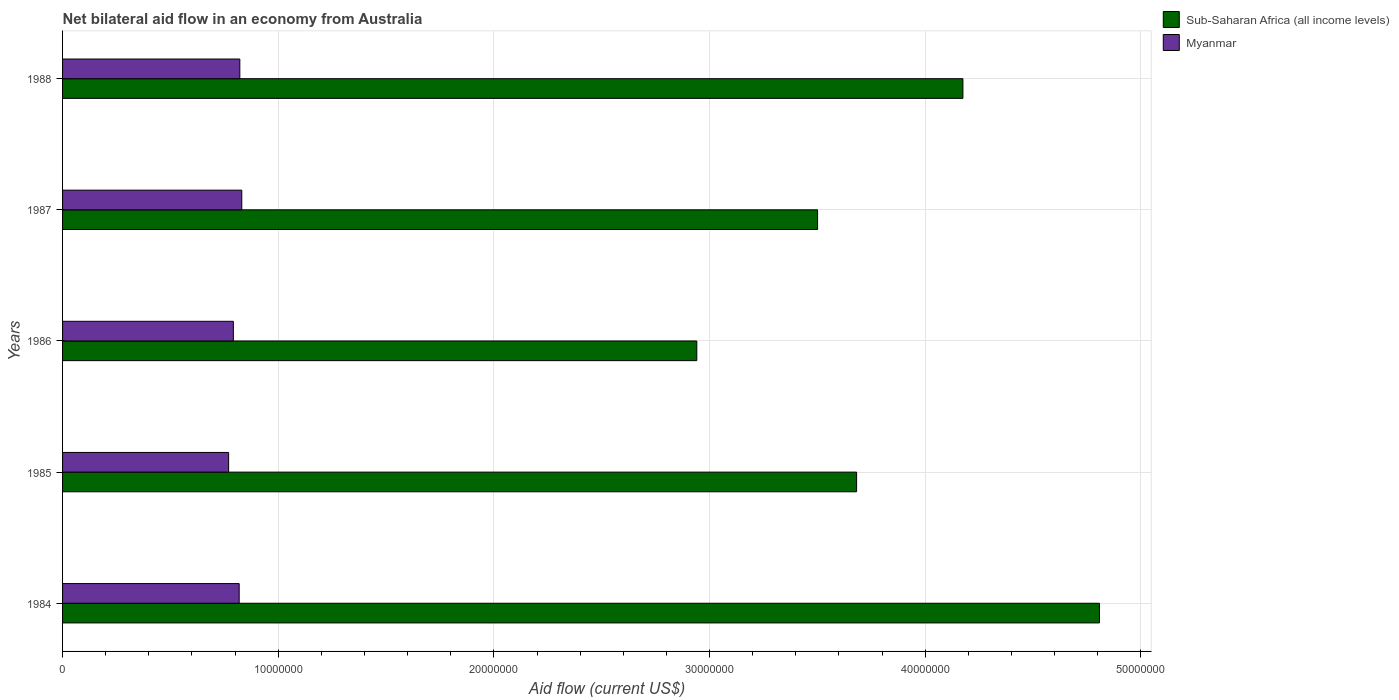How many groups of bars are there?
Provide a succinct answer. 5. Are the number of bars per tick equal to the number of legend labels?
Keep it short and to the point. Yes. How many bars are there on the 1st tick from the top?
Give a very brief answer. 2. How many bars are there on the 5th tick from the bottom?
Offer a very short reply. 2. What is the label of the 3rd group of bars from the top?
Offer a very short reply. 1986. In how many cases, is the number of bars for a given year not equal to the number of legend labels?
Provide a short and direct response. 0. What is the net bilateral aid flow in Sub-Saharan Africa (all income levels) in 1987?
Your answer should be very brief. 3.50e+07. Across all years, what is the maximum net bilateral aid flow in Myanmar?
Provide a short and direct response. 8.31e+06. Across all years, what is the minimum net bilateral aid flow in Sub-Saharan Africa (all income levels)?
Your answer should be very brief. 2.94e+07. In which year was the net bilateral aid flow in Sub-Saharan Africa (all income levels) minimum?
Keep it short and to the point. 1986. What is the total net bilateral aid flow in Myanmar in the graph?
Provide a succinct answer. 4.03e+07. What is the difference between the net bilateral aid flow in Myanmar in 1985 and that in 1987?
Keep it short and to the point. -6.10e+05. What is the difference between the net bilateral aid flow in Sub-Saharan Africa (all income levels) in 1987 and the net bilateral aid flow in Myanmar in 1984?
Your answer should be compact. 2.68e+07. What is the average net bilateral aid flow in Sub-Saharan Africa (all income levels) per year?
Make the answer very short. 3.82e+07. In the year 1984, what is the difference between the net bilateral aid flow in Sub-Saharan Africa (all income levels) and net bilateral aid flow in Myanmar?
Provide a short and direct response. 3.99e+07. What is the ratio of the net bilateral aid flow in Sub-Saharan Africa (all income levels) in 1984 to that in 1985?
Make the answer very short. 1.31. Is the net bilateral aid flow in Myanmar in 1984 less than that in 1986?
Your answer should be compact. No. Is the difference between the net bilateral aid flow in Sub-Saharan Africa (all income levels) in 1985 and 1988 greater than the difference between the net bilateral aid flow in Myanmar in 1985 and 1988?
Offer a very short reply. No. What is the difference between the highest and the second highest net bilateral aid flow in Myanmar?
Offer a very short reply. 9.00e+04. What is the difference between the highest and the lowest net bilateral aid flow in Myanmar?
Offer a terse response. 6.10e+05. In how many years, is the net bilateral aid flow in Sub-Saharan Africa (all income levels) greater than the average net bilateral aid flow in Sub-Saharan Africa (all income levels) taken over all years?
Your answer should be compact. 2. Is the sum of the net bilateral aid flow in Myanmar in 1984 and 1988 greater than the maximum net bilateral aid flow in Sub-Saharan Africa (all income levels) across all years?
Make the answer very short. No. What does the 2nd bar from the top in 1988 represents?
Ensure brevity in your answer.  Sub-Saharan Africa (all income levels). What does the 2nd bar from the bottom in 1985 represents?
Provide a succinct answer. Myanmar. What is the difference between two consecutive major ticks on the X-axis?
Make the answer very short. 1.00e+07. Are the values on the major ticks of X-axis written in scientific E-notation?
Give a very brief answer. No. Does the graph contain any zero values?
Give a very brief answer. No. Where does the legend appear in the graph?
Your answer should be compact. Top right. What is the title of the graph?
Make the answer very short. Net bilateral aid flow in an economy from Australia. Does "Dominica" appear as one of the legend labels in the graph?
Your answer should be compact. No. What is the label or title of the Y-axis?
Offer a very short reply. Years. What is the Aid flow (current US$) in Sub-Saharan Africa (all income levels) in 1984?
Your answer should be very brief. 4.81e+07. What is the Aid flow (current US$) in Myanmar in 1984?
Your answer should be compact. 8.19e+06. What is the Aid flow (current US$) of Sub-Saharan Africa (all income levels) in 1985?
Your response must be concise. 3.68e+07. What is the Aid flow (current US$) of Myanmar in 1985?
Give a very brief answer. 7.70e+06. What is the Aid flow (current US$) of Sub-Saharan Africa (all income levels) in 1986?
Offer a terse response. 2.94e+07. What is the Aid flow (current US$) of Myanmar in 1986?
Your response must be concise. 7.92e+06. What is the Aid flow (current US$) of Sub-Saharan Africa (all income levels) in 1987?
Give a very brief answer. 3.50e+07. What is the Aid flow (current US$) of Myanmar in 1987?
Offer a very short reply. 8.31e+06. What is the Aid flow (current US$) of Sub-Saharan Africa (all income levels) in 1988?
Provide a short and direct response. 4.18e+07. What is the Aid flow (current US$) in Myanmar in 1988?
Your response must be concise. 8.22e+06. Across all years, what is the maximum Aid flow (current US$) of Sub-Saharan Africa (all income levels)?
Your answer should be compact. 4.81e+07. Across all years, what is the maximum Aid flow (current US$) of Myanmar?
Provide a short and direct response. 8.31e+06. Across all years, what is the minimum Aid flow (current US$) in Sub-Saharan Africa (all income levels)?
Your answer should be compact. 2.94e+07. Across all years, what is the minimum Aid flow (current US$) of Myanmar?
Provide a short and direct response. 7.70e+06. What is the total Aid flow (current US$) in Sub-Saharan Africa (all income levels) in the graph?
Your answer should be compact. 1.91e+08. What is the total Aid flow (current US$) of Myanmar in the graph?
Make the answer very short. 4.03e+07. What is the difference between the Aid flow (current US$) in Sub-Saharan Africa (all income levels) in 1984 and that in 1985?
Your answer should be compact. 1.13e+07. What is the difference between the Aid flow (current US$) in Sub-Saharan Africa (all income levels) in 1984 and that in 1986?
Your answer should be compact. 1.87e+07. What is the difference between the Aid flow (current US$) of Myanmar in 1984 and that in 1986?
Give a very brief answer. 2.70e+05. What is the difference between the Aid flow (current US$) in Sub-Saharan Africa (all income levels) in 1984 and that in 1987?
Keep it short and to the point. 1.31e+07. What is the difference between the Aid flow (current US$) in Sub-Saharan Africa (all income levels) in 1984 and that in 1988?
Provide a short and direct response. 6.33e+06. What is the difference between the Aid flow (current US$) in Myanmar in 1984 and that in 1988?
Offer a terse response. -3.00e+04. What is the difference between the Aid flow (current US$) in Sub-Saharan Africa (all income levels) in 1985 and that in 1986?
Make the answer very short. 7.41e+06. What is the difference between the Aid flow (current US$) in Myanmar in 1985 and that in 1986?
Your answer should be compact. -2.20e+05. What is the difference between the Aid flow (current US$) in Sub-Saharan Africa (all income levels) in 1985 and that in 1987?
Your response must be concise. 1.81e+06. What is the difference between the Aid flow (current US$) in Myanmar in 1985 and that in 1987?
Keep it short and to the point. -6.10e+05. What is the difference between the Aid flow (current US$) of Sub-Saharan Africa (all income levels) in 1985 and that in 1988?
Provide a succinct answer. -4.93e+06. What is the difference between the Aid flow (current US$) in Myanmar in 1985 and that in 1988?
Offer a terse response. -5.20e+05. What is the difference between the Aid flow (current US$) in Sub-Saharan Africa (all income levels) in 1986 and that in 1987?
Provide a short and direct response. -5.60e+06. What is the difference between the Aid flow (current US$) in Myanmar in 1986 and that in 1987?
Your response must be concise. -3.90e+05. What is the difference between the Aid flow (current US$) in Sub-Saharan Africa (all income levels) in 1986 and that in 1988?
Provide a succinct answer. -1.23e+07. What is the difference between the Aid flow (current US$) of Myanmar in 1986 and that in 1988?
Your response must be concise. -3.00e+05. What is the difference between the Aid flow (current US$) in Sub-Saharan Africa (all income levels) in 1987 and that in 1988?
Keep it short and to the point. -6.74e+06. What is the difference between the Aid flow (current US$) of Myanmar in 1987 and that in 1988?
Offer a very short reply. 9.00e+04. What is the difference between the Aid flow (current US$) in Sub-Saharan Africa (all income levels) in 1984 and the Aid flow (current US$) in Myanmar in 1985?
Your answer should be very brief. 4.04e+07. What is the difference between the Aid flow (current US$) of Sub-Saharan Africa (all income levels) in 1984 and the Aid flow (current US$) of Myanmar in 1986?
Your response must be concise. 4.02e+07. What is the difference between the Aid flow (current US$) in Sub-Saharan Africa (all income levels) in 1984 and the Aid flow (current US$) in Myanmar in 1987?
Your response must be concise. 3.98e+07. What is the difference between the Aid flow (current US$) in Sub-Saharan Africa (all income levels) in 1984 and the Aid flow (current US$) in Myanmar in 1988?
Give a very brief answer. 3.99e+07. What is the difference between the Aid flow (current US$) in Sub-Saharan Africa (all income levels) in 1985 and the Aid flow (current US$) in Myanmar in 1986?
Your answer should be very brief. 2.89e+07. What is the difference between the Aid flow (current US$) in Sub-Saharan Africa (all income levels) in 1985 and the Aid flow (current US$) in Myanmar in 1987?
Your response must be concise. 2.85e+07. What is the difference between the Aid flow (current US$) in Sub-Saharan Africa (all income levels) in 1985 and the Aid flow (current US$) in Myanmar in 1988?
Offer a terse response. 2.86e+07. What is the difference between the Aid flow (current US$) of Sub-Saharan Africa (all income levels) in 1986 and the Aid flow (current US$) of Myanmar in 1987?
Offer a terse response. 2.11e+07. What is the difference between the Aid flow (current US$) of Sub-Saharan Africa (all income levels) in 1986 and the Aid flow (current US$) of Myanmar in 1988?
Provide a short and direct response. 2.12e+07. What is the difference between the Aid flow (current US$) in Sub-Saharan Africa (all income levels) in 1987 and the Aid flow (current US$) in Myanmar in 1988?
Keep it short and to the point. 2.68e+07. What is the average Aid flow (current US$) in Sub-Saharan Africa (all income levels) per year?
Your response must be concise. 3.82e+07. What is the average Aid flow (current US$) of Myanmar per year?
Offer a very short reply. 8.07e+06. In the year 1984, what is the difference between the Aid flow (current US$) in Sub-Saharan Africa (all income levels) and Aid flow (current US$) in Myanmar?
Offer a terse response. 3.99e+07. In the year 1985, what is the difference between the Aid flow (current US$) of Sub-Saharan Africa (all income levels) and Aid flow (current US$) of Myanmar?
Give a very brief answer. 2.91e+07. In the year 1986, what is the difference between the Aid flow (current US$) of Sub-Saharan Africa (all income levels) and Aid flow (current US$) of Myanmar?
Keep it short and to the point. 2.15e+07. In the year 1987, what is the difference between the Aid flow (current US$) of Sub-Saharan Africa (all income levels) and Aid flow (current US$) of Myanmar?
Your answer should be very brief. 2.67e+07. In the year 1988, what is the difference between the Aid flow (current US$) in Sub-Saharan Africa (all income levels) and Aid flow (current US$) in Myanmar?
Provide a short and direct response. 3.35e+07. What is the ratio of the Aid flow (current US$) of Sub-Saharan Africa (all income levels) in 1984 to that in 1985?
Give a very brief answer. 1.31. What is the ratio of the Aid flow (current US$) of Myanmar in 1984 to that in 1985?
Your answer should be compact. 1.06. What is the ratio of the Aid flow (current US$) in Sub-Saharan Africa (all income levels) in 1984 to that in 1986?
Provide a succinct answer. 1.63. What is the ratio of the Aid flow (current US$) in Myanmar in 1984 to that in 1986?
Offer a terse response. 1.03. What is the ratio of the Aid flow (current US$) in Sub-Saharan Africa (all income levels) in 1984 to that in 1987?
Offer a terse response. 1.37. What is the ratio of the Aid flow (current US$) of Myanmar in 1984 to that in 1987?
Keep it short and to the point. 0.99. What is the ratio of the Aid flow (current US$) of Sub-Saharan Africa (all income levels) in 1984 to that in 1988?
Offer a terse response. 1.15. What is the ratio of the Aid flow (current US$) of Sub-Saharan Africa (all income levels) in 1985 to that in 1986?
Keep it short and to the point. 1.25. What is the ratio of the Aid flow (current US$) in Myanmar in 1985 to that in 1986?
Give a very brief answer. 0.97. What is the ratio of the Aid flow (current US$) of Sub-Saharan Africa (all income levels) in 1985 to that in 1987?
Your answer should be compact. 1.05. What is the ratio of the Aid flow (current US$) of Myanmar in 1985 to that in 1987?
Give a very brief answer. 0.93. What is the ratio of the Aid flow (current US$) in Sub-Saharan Africa (all income levels) in 1985 to that in 1988?
Give a very brief answer. 0.88. What is the ratio of the Aid flow (current US$) in Myanmar in 1985 to that in 1988?
Provide a succinct answer. 0.94. What is the ratio of the Aid flow (current US$) of Sub-Saharan Africa (all income levels) in 1986 to that in 1987?
Your answer should be compact. 0.84. What is the ratio of the Aid flow (current US$) in Myanmar in 1986 to that in 1987?
Keep it short and to the point. 0.95. What is the ratio of the Aid flow (current US$) in Sub-Saharan Africa (all income levels) in 1986 to that in 1988?
Offer a terse response. 0.7. What is the ratio of the Aid flow (current US$) of Myanmar in 1986 to that in 1988?
Ensure brevity in your answer.  0.96. What is the ratio of the Aid flow (current US$) of Sub-Saharan Africa (all income levels) in 1987 to that in 1988?
Your answer should be very brief. 0.84. What is the ratio of the Aid flow (current US$) of Myanmar in 1987 to that in 1988?
Keep it short and to the point. 1.01. What is the difference between the highest and the second highest Aid flow (current US$) in Sub-Saharan Africa (all income levels)?
Your answer should be compact. 6.33e+06. What is the difference between the highest and the lowest Aid flow (current US$) of Sub-Saharan Africa (all income levels)?
Offer a very short reply. 1.87e+07. What is the difference between the highest and the lowest Aid flow (current US$) of Myanmar?
Your answer should be very brief. 6.10e+05. 